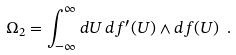<formula> <loc_0><loc_0><loc_500><loc_500>\Omega _ { 2 } = \int _ { - \infty } ^ { \infty } d U \, d f ^ { \prime } ( U ) \wedge d f ( U ) \ .</formula> 